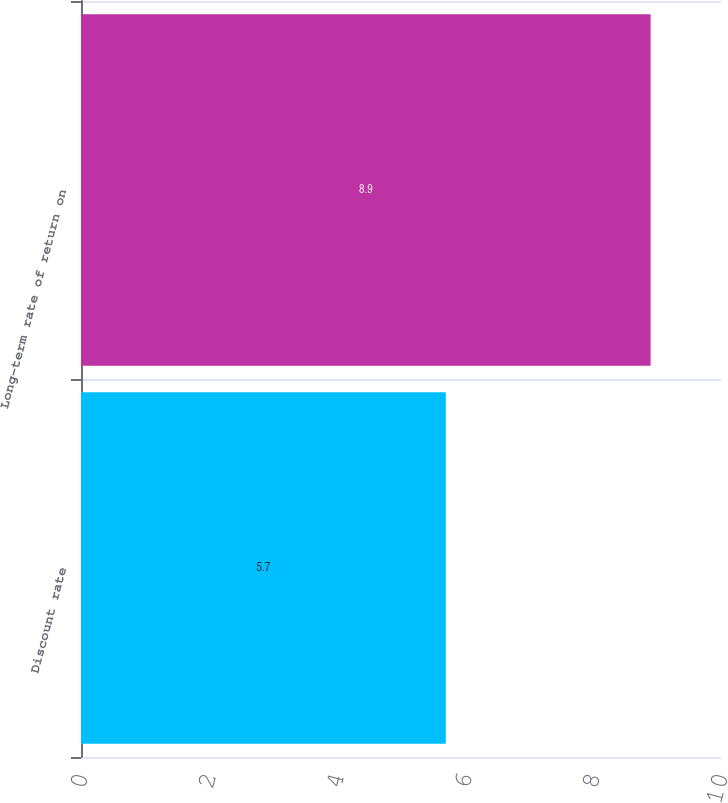<chart> <loc_0><loc_0><loc_500><loc_500><bar_chart><fcel>Discount rate<fcel>Long-term rate of return on<nl><fcel>5.7<fcel>8.9<nl></chart> 